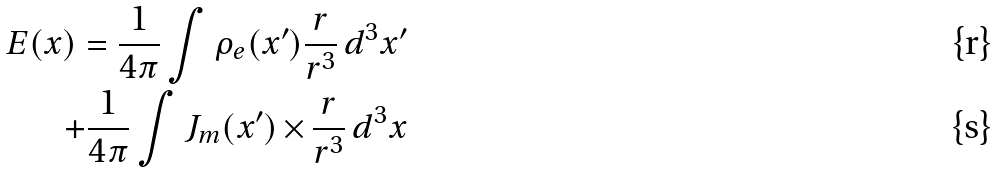<formula> <loc_0><loc_0><loc_500><loc_500>E ( x ) = \frac { 1 } { 4 \pi } \int \rho _ { e } ( x ^ { \prime } ) \frac { r } { r ^ { 3 } } \, d ^ { 3 } x ^ { \prime } \\ + \frac { 1 } { 4 \pi } \int J _ { m } ( x ^ { \prime } ) \, { \times } \, \frac { r } { r ^ { 3 } } \, d ^ { 3 } x</formula> 